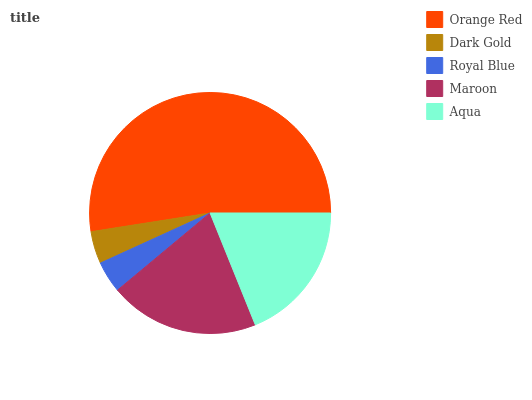Is Royal Blue the minimum?
Answer yes or no. Yes. Is Orange Red the maximum?
Answer yes or no. Yes. Is Dark Gold the minimum?
Answer yes or no. No. Is Dark Gold the maximum?
Answer yes or no. No. Is Orange Red greater than Dark Gold?
Answer yes or no. Yes. Is Dark Gold less than Orange Red?
Answer yes or no. Yes. Is Dark Gold greater than Orange Red?
Answer yes or no. No. Is Orange Red less than Dark Gold?
Answer yes or no. No. Is Aqua the high median?
Answer yes or no. Yes. Is Aqua the low median?
Answer yes or no. Yes. Is Royal Blue the high median?
Answer yes or no. No. Is Royal Blue the low median?
Answer yes or no. No. 